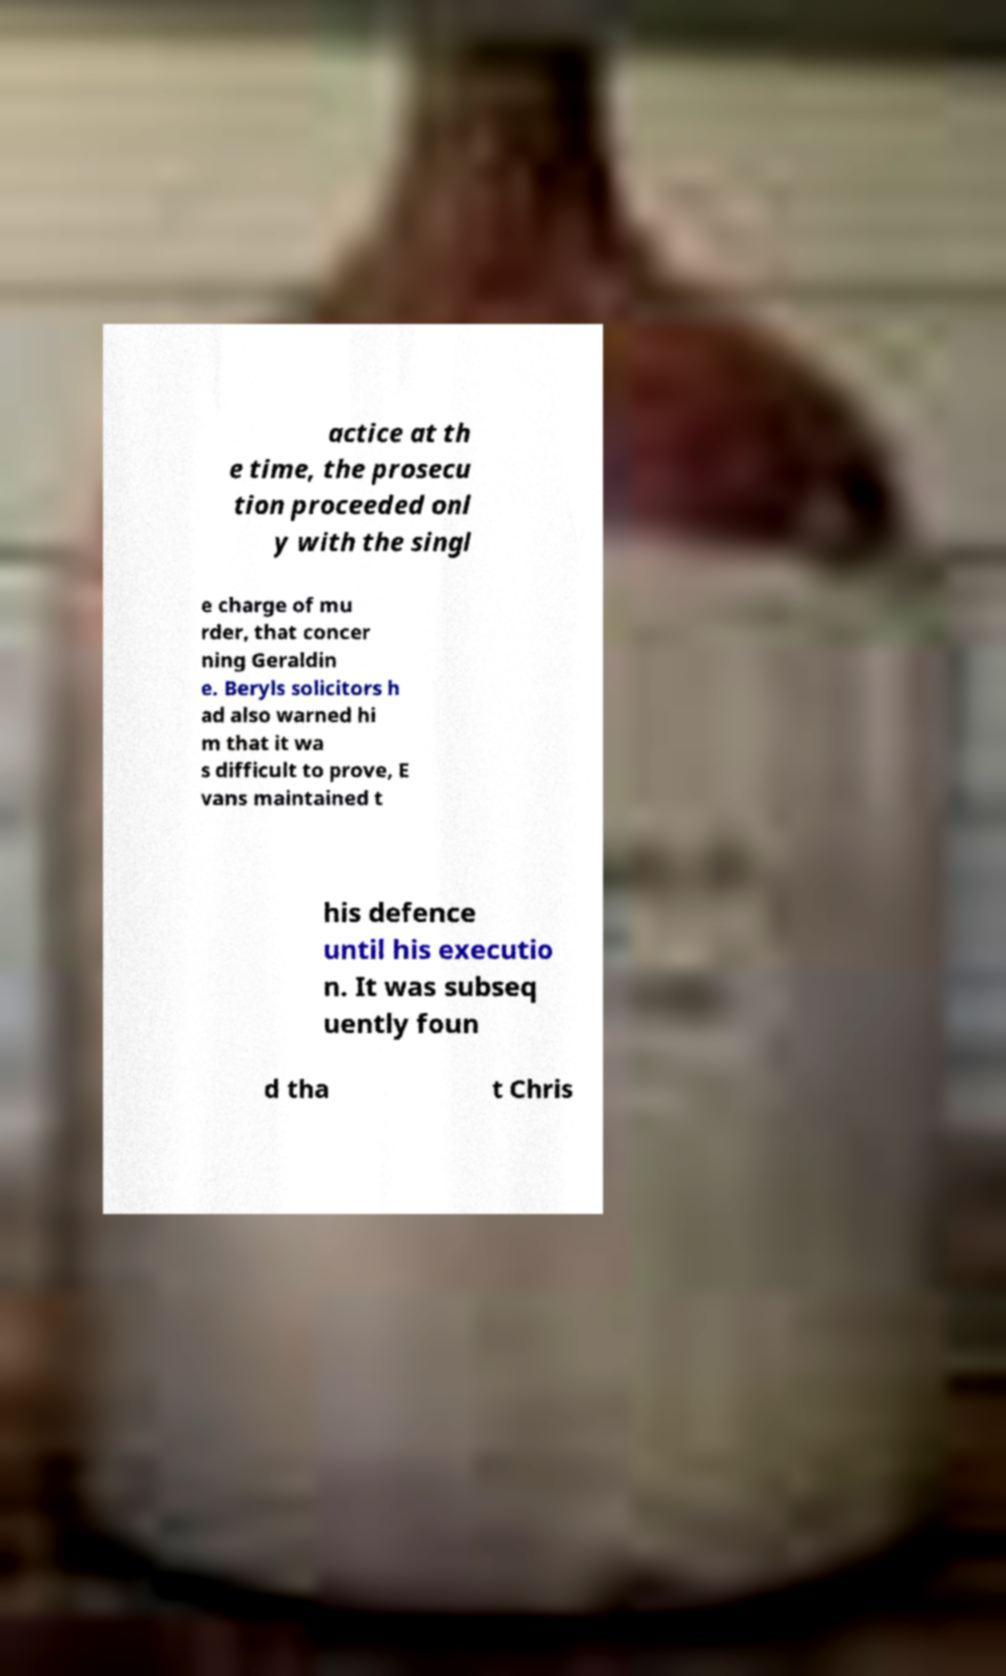Could you extract and type out the text from this image? actice at th e time, the prosecu tion proceeded onl y with the singl e charge of mu rder, that concer ning Geraldin e. Beryls solicitors h ad also warned hi m that it wa s difficult to prove, E vans maintained t his defence until his executio n. It was subseq uently foun d tha t Chris 